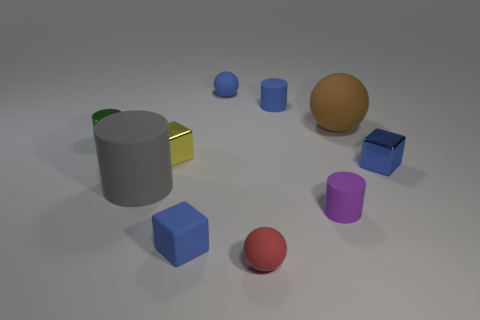Subtract all spheres. How many objects are left? 7 Add 1 large brown objects. How many large brown objects are left? 2 Add 9 big gray rubber objects. How many big gray rubber objects exist? 10 Subtract 0 green spheres. How many objects are left? 10 Subtract all big shiny things. Subtract all blue matte things. How many objects are left? 7 